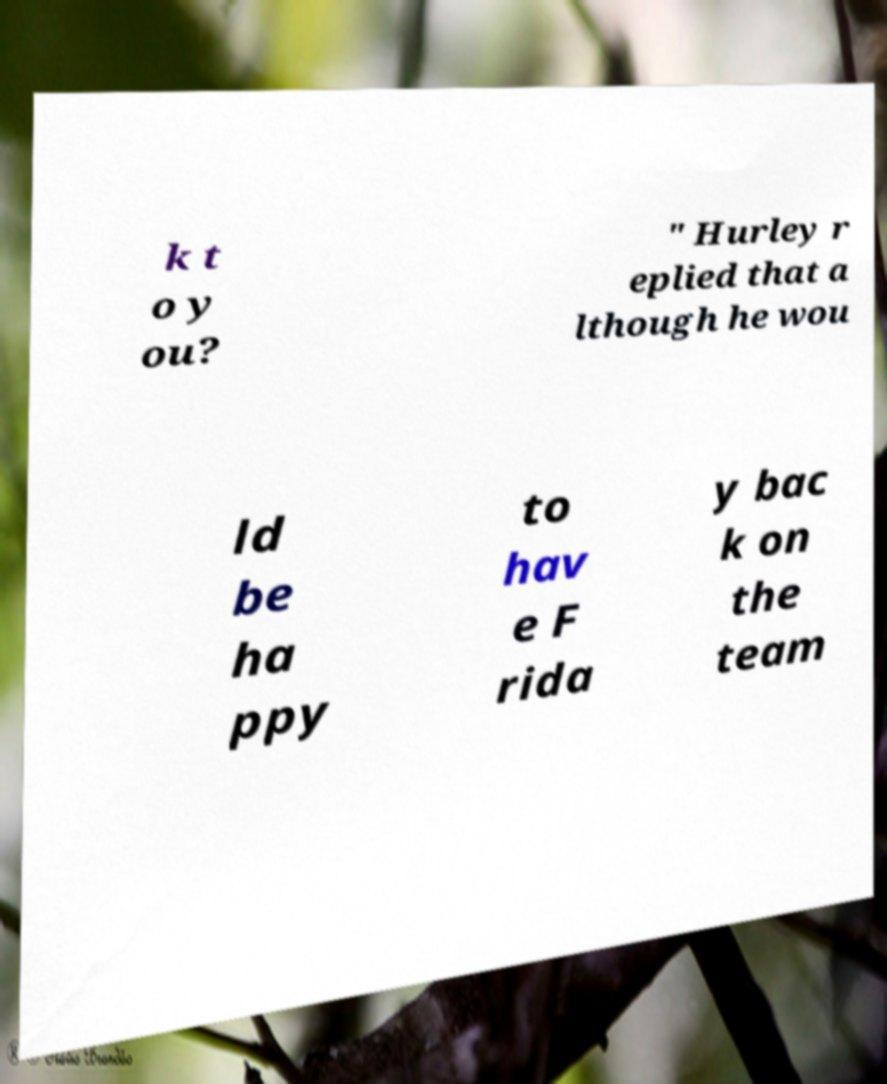For documentation purposes, I need the text within this image transcribed. Could you provide that? k t o y ou? " Hurley r eplied that a lthough he wou ld be ha ppy to hav e F rida y bac k on the team 